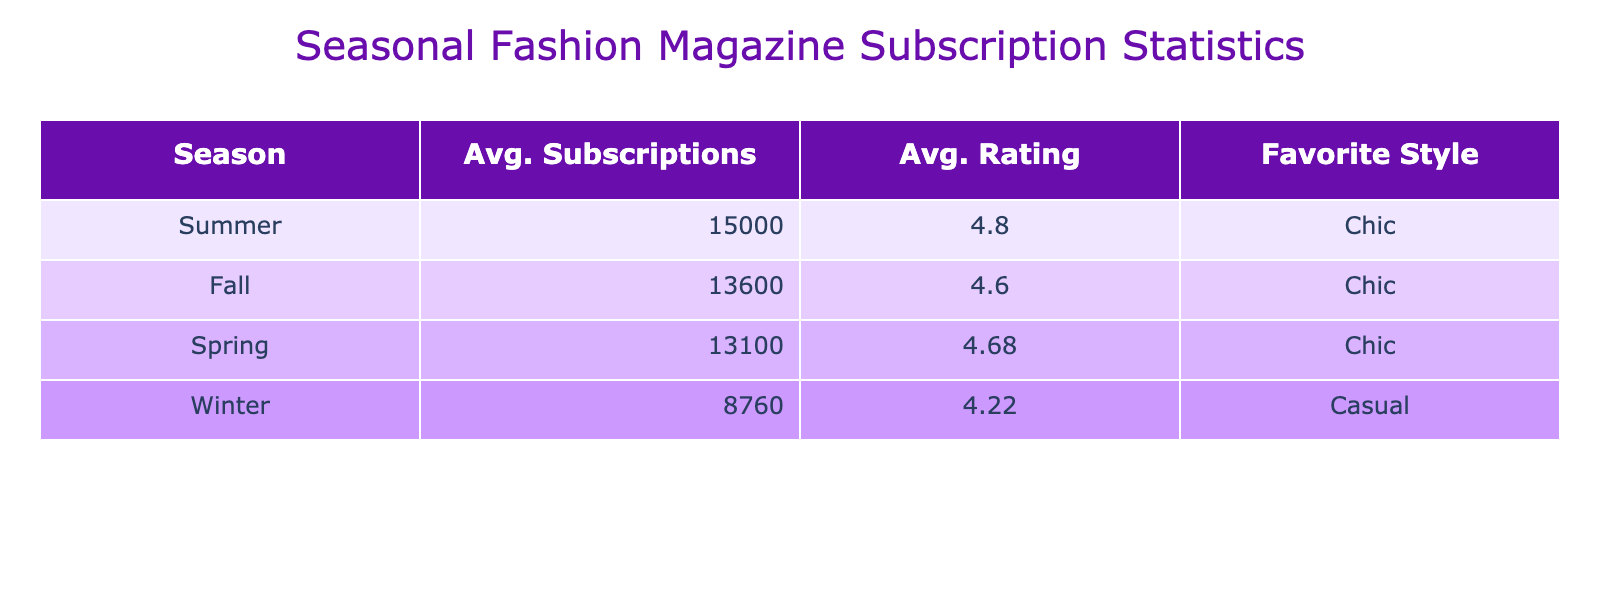What is the average number of subscriptions during the Summer season? To find the average for the Summer season, we can look at the Subscription_Count for Summer across all years: 15000 (2019), 14000 (2020), 14500 (2021), 16000 (2022), and 15500 (2023). The sum is 15000 + 14000 + 14500 + 16000 + 15500 = 75000. There are 5 entries, so we divide the total by 5: 75000 / 5 = 15000.
Answer: 15000 Is the average issue rating for Fall higher than that for Winter? From the table, the average issue rating for Fall is 4.6, while for Winter it is 4.3. Since 4.6 is greater than 4.3, the statement is true.
Answer: Yes What is the total subscription count for the Winter season over the five years? We look at the Subscription_Count for Winter for each year: 8000 (2019), 9000 (2020), 8500 (2021), 8800 (2022), and 9500 (2023). Adding these values together gives: 8000 + 9000 + 8500 + 8800 + 9500 = 43800.
Answer: 43800 Which season had the highest average subscription count? Reviewing the average subscription counts for each season: Spring - 12900, Summer - 15000, Fall - 12600, Winter - 8340. Summer has the highest average subscription count at 15000.
Answer: Summer What is the percentage increase in average subscriptions from Winter 2022 to Spring 2023? First, we find the average subscriptions for Winter 2022 (8800) and Spring 2023 (14500). The difference is 14500 - 8800 = 5700. To find the percentage increase, we divide the difference by the Winter 2022 average and then multiply by 100: (5700 / 8800) * 100 = 64.77%.
Answer: 64.77% Did the average subscription count increase every year from Spring 2019 to Spring 2023? We trace the average subscriptions from Spring 2019 (12000), Spring 2020 (12500), Spring 2021 (13000), Spring 2022 (13500), and Spring 2023 (14500). The trend shows consistent yearly increases, confirming that the count did rise every year.
Answer: Yes What was the average rating of the Chic style compared to the Casual style over the years? To find this, we calculate the average rating for Chic (4.5, 4.6, 4.8, 4.7, 4.7, 4.8, 4.9, 4.7) = 4.70 and Casual (4.2, 4.3, 4.1, 4.2, 4.3) = 4.22. Comparatively, Chic is rated higher than Casual.
Answer: Chic What is the average issue rating for the year with the lowest average subscriptions? We first identify the year with the lowest average subscriptions, which is Winter across all years (8340). The average issue rating for Winter is 4.3. Therefore, the average issue rating connected to the lowest subscriptions is 4.3.
Answer: 4.3 